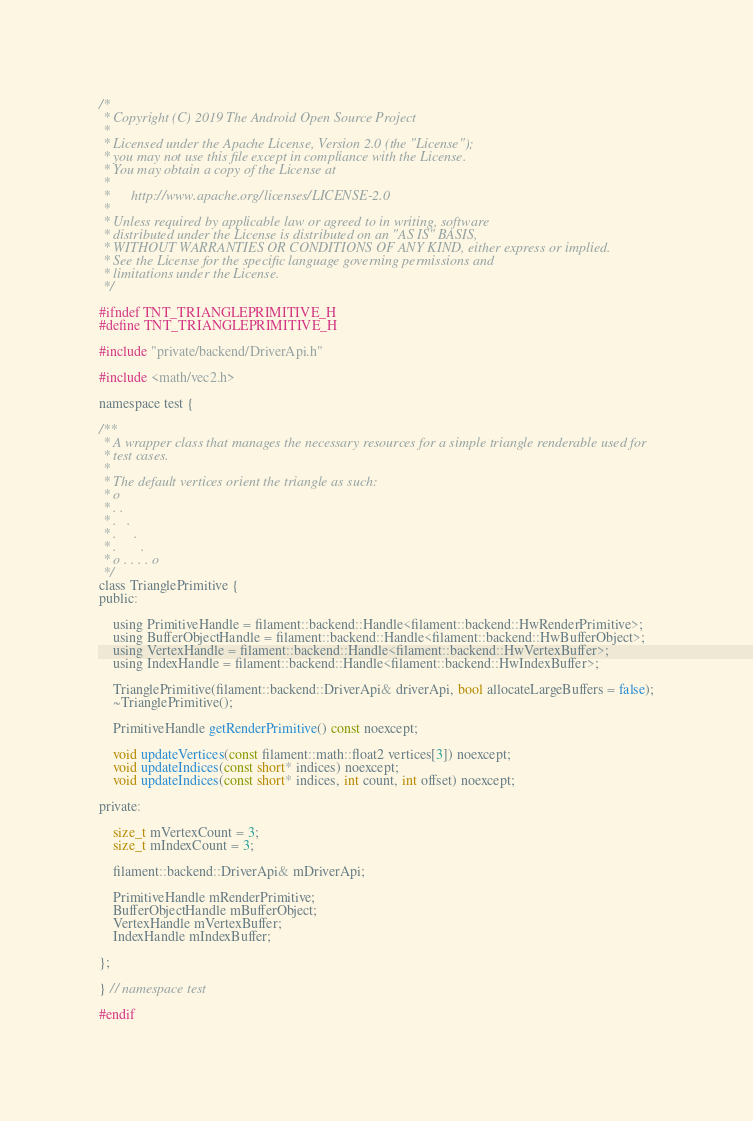<code> <loc_0><loc_0><loc_500><loc_500><_C_>/*
 * Copyright (C) 2019 The Android Open Source Project
 *
 * Licensed under the Apache License, Version 2.0 (the "License");
 * you may not use this file except in compliance with the License.
 * You may obtain a copy of the License at
 *
 *      http://www.apache.org/licenses/LICENSE-2.0
 *
 * Unless required by applicable law or agreed to in writing, software
 * distributed under the License is distributed on an "AS IS" BASIS,
 * WITHOUT WARRANTIES OR CONDITIONS OF ANY KIND, either express or implied.
 * See the License for the specific language governing permissions and
 * limitations under the License.
 */

#ifndef TNT_TRIANGLEPRIMITIVE_H
#define TNT_TRIANGLEPRIMITIVE_H

#include "private/backend/DriverApi.h"

#include <math/vec2.h>

namespace test {

/**
 * A wrapper class that manages the necessary resources for a simple triangle renderable used for
 * test cases.
 *
 * The default vertices orient the triangle as such:
 * o
 * . .
 * .   .
 * .     .
 * .       .
 * o . . . . o
 */
class TrianglePrimitive {
public:

    using PrimitiveHandle = filament::backend::Handle<filament::backend::HwRenderPrimitive>;
    using BufferObjectHandle = filament::backend::Handle<filament::backend::HwBufferObject>;
    using VertexHandle = filament::backend::Handle<filament::backend::HwVertexBuffer>;
    using IndexHandle = filament::backend::Handle<filament::backend::HwIndexBuffer>;

    TrianglePrimitive(filament::backend::DriverApi& driverApi, bool allocateLargeBuffers = false);
    ~TrianglePrimitive();

    PrimitiveHandle getRenderPrimitive() const noexcept;

    void updateVertices(const filament::math::float2 vertices[3]) noexcept;
    void updateIndices(const short* indices) noexcept;
    void updateIndices(const short* indices, int count, int offset) noexcept;

private:

    size_t mVertexCount = 3;
    size_t mIndexCount = 3;

    filament::backend::DriverApi& mDriverApi;

    PrimitiveHandle mRenderPrimitive;
    BufferObjectHandle mBufferObject;
    VertexHandle mVertexBuffer;
    IndexHandle mIndexBuffer;

};

} // namespace test

#endif
</code> 